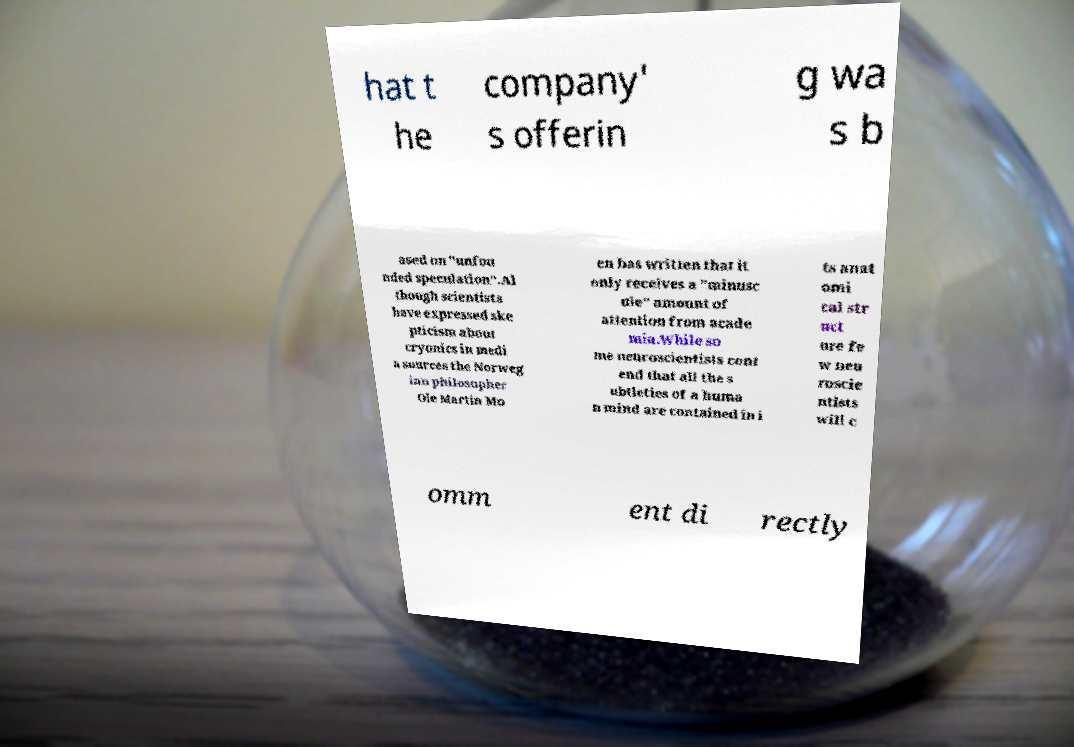There's text embedded in this image that I need extracted. Can you transcribe it verbatim? hat t he company' s offerin g wa s b ased on "unfou nded speculation".Al though scientists have expressed ske pticism about cryonics in medi a sources the Norweg ian philosopher Ole Martin Mo en has written that it only receives a "minusc ule" amount of attention from acade mia.While so me neuroscientists cont end that all the s ubtleties of a huma n mind are contained in i ts anat omi cal str uct ure fe w neu roscie ntists will c omm ent di rectly 